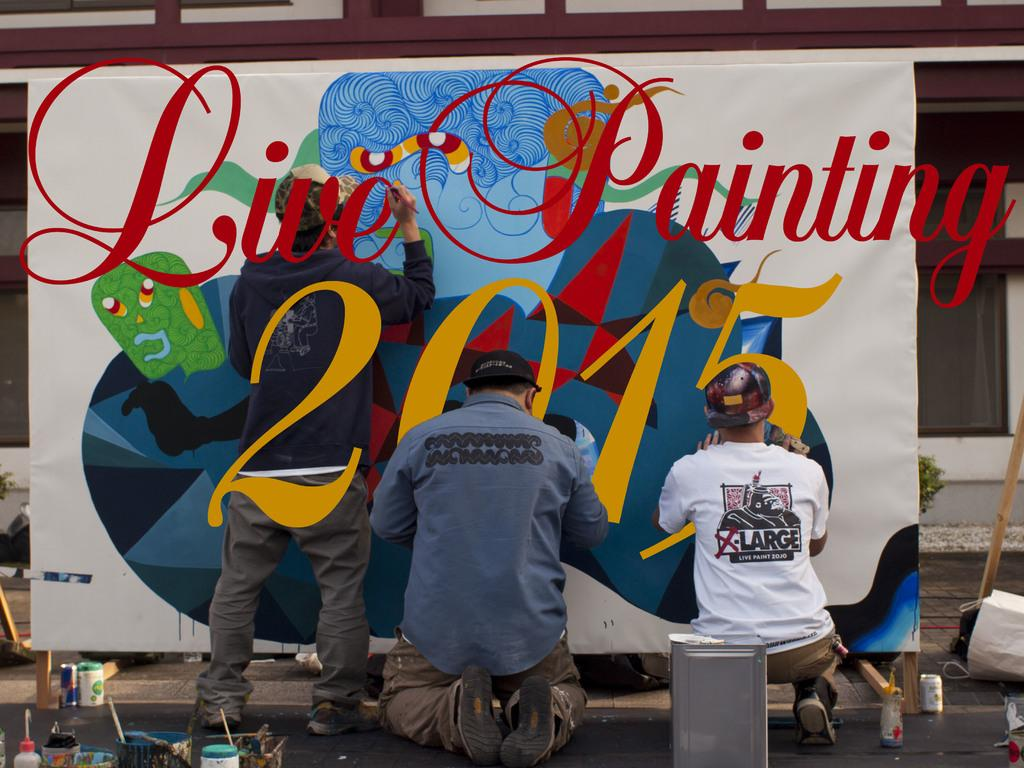How many people are engaged in painting in the image? There are 3 people painting in the image. What materials are used for painting in the image? There are paints in the image. What is the container used for in the image? There is a container in the image, which might be used for holding paints or other materials. Can you describe any other objects present in the image? There are other objects in the image, but their specific purpose or appearance is not mentioned in the provided facts. What can be seen in the background of the image? There is a building in the background of the image. How many oranges are being used as balls in the image? There are no oranges or balls present in the image. What type of toys can be seen in the image? There is no mention of toys in the provided facts, so we cannot determine if any are present in the image. 